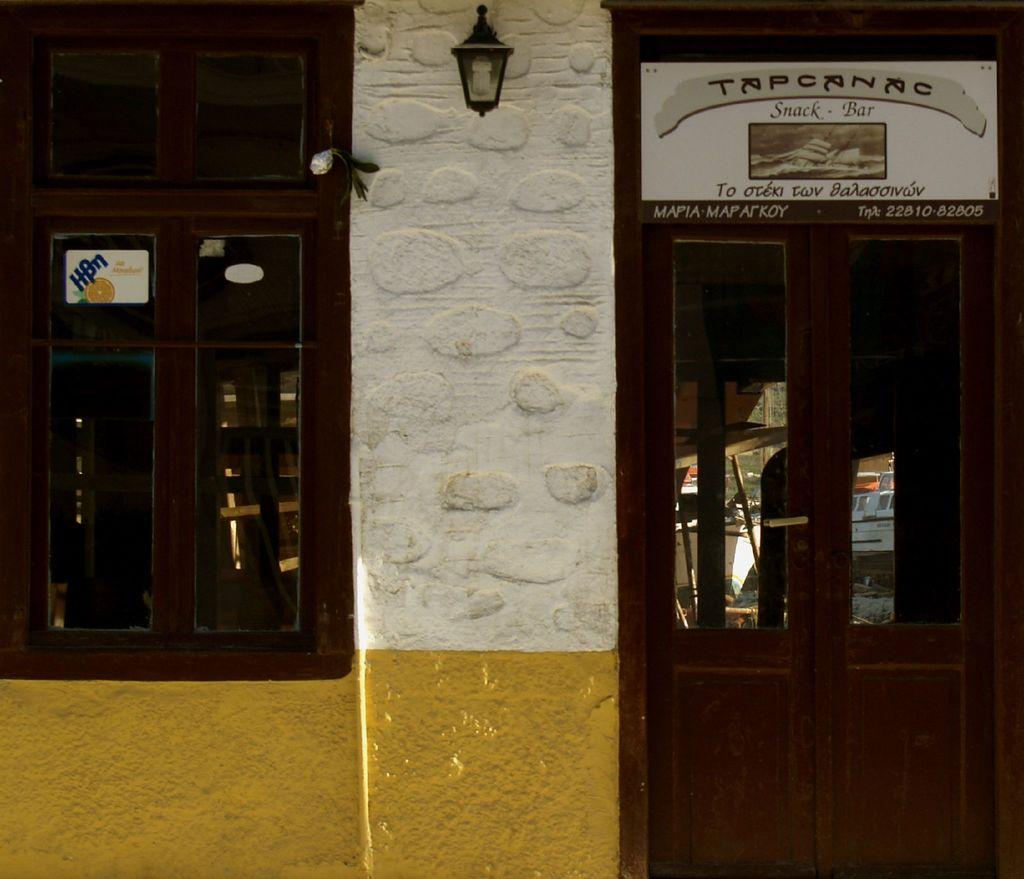What type of opening can be seen in the image? There is a window in the image. What other architectural feature is present in the image? There is a door in the image. What is written on the board in the image? There is a board with text in the image. Where is the street lamp located in the image? The street lamp is on a wall in the image. What type of book is being read under the street lamp in the image? There is no book or person reading in the image; it only features a street lamp on a wall. What caption is written on the window in the image? There is no caption on the window in the image; it is just a window. 